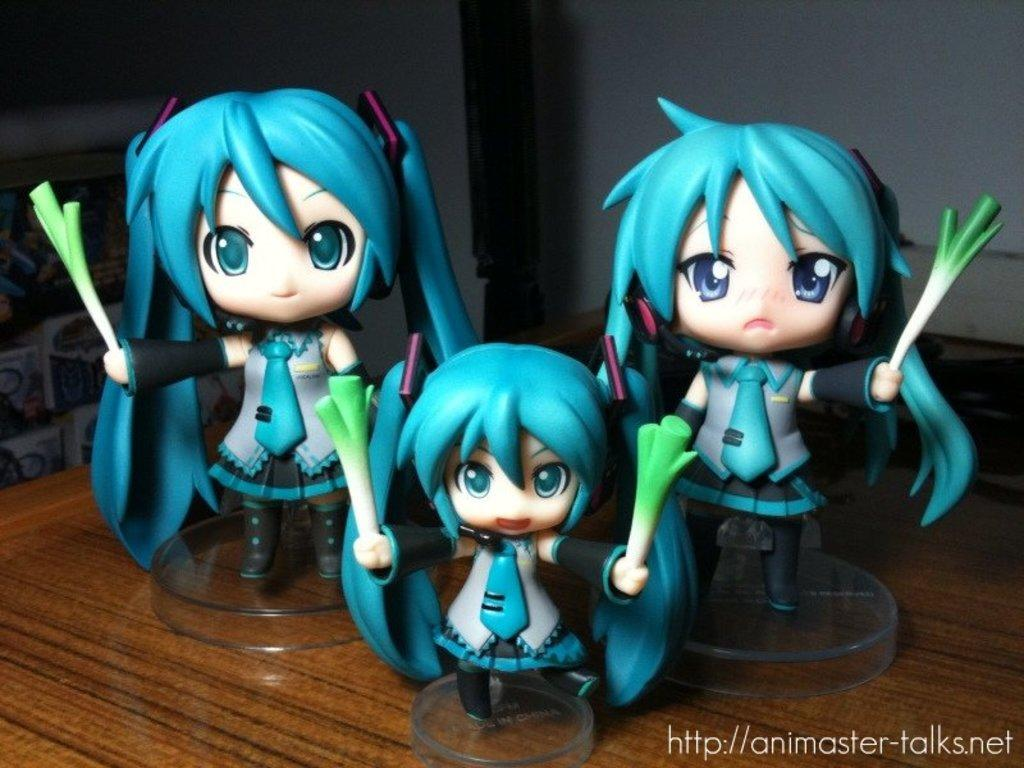How many toys are visible in the image? There are three toys in the image. What is the color of the surface on which the toys are placed? The toys are on a brown surface. What colors are the toys? The toys are in green and cream colors. What color is the background wall in the image? The background wall is white. How many circles can be seen on the toys in the image? There is no mention of circles on the toys in the image; the toys are described as being in green and cream colors. 